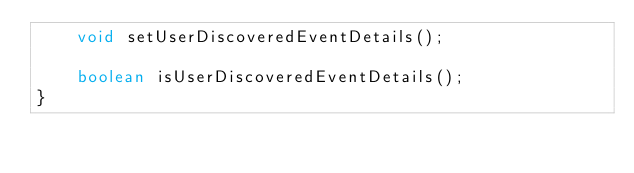<code> <loc_0><loc_0><loc_500><loc_500><_Java_>    void setUserDiscoveredEventDetails();

    boolean isUserDiscoveredEventDetails();
}
</code> 